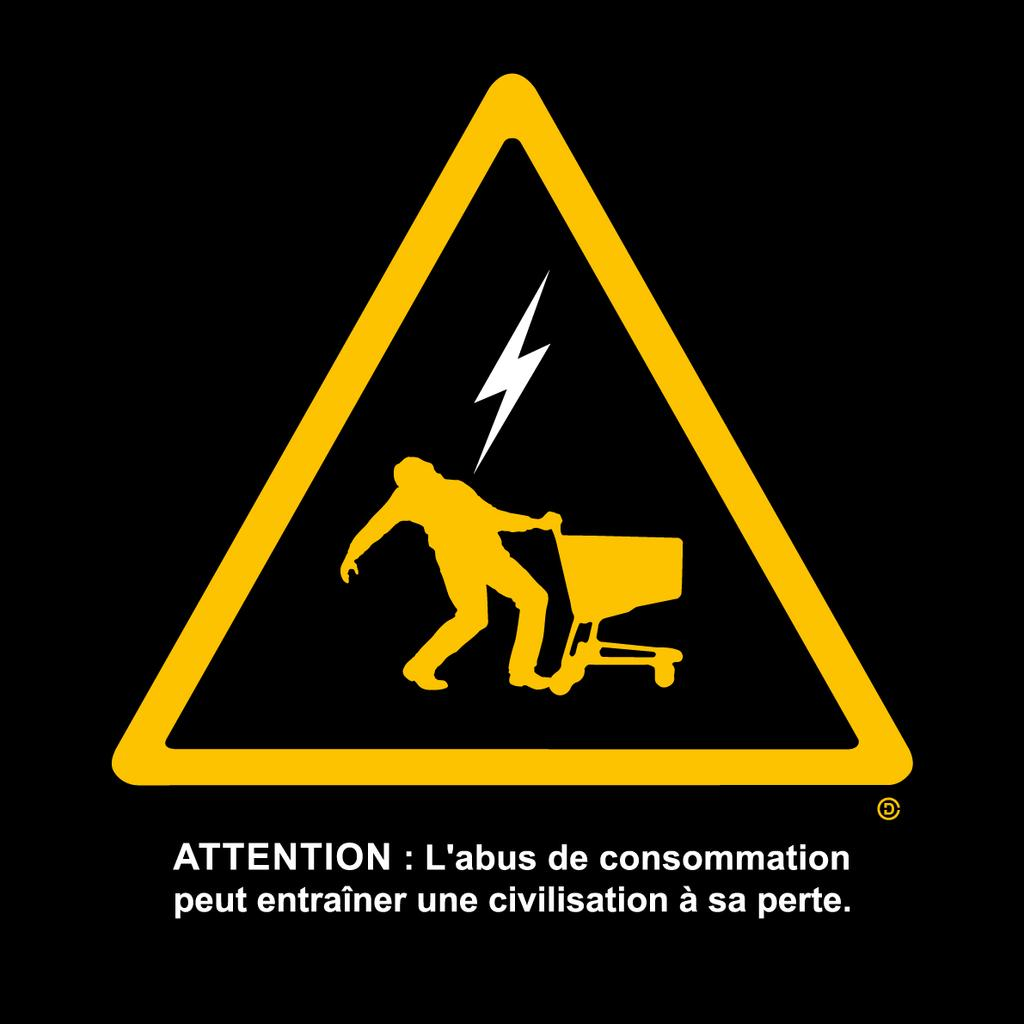<image>
Give a short and clear explanation of the subsequent image. a sign that says attention on the front 